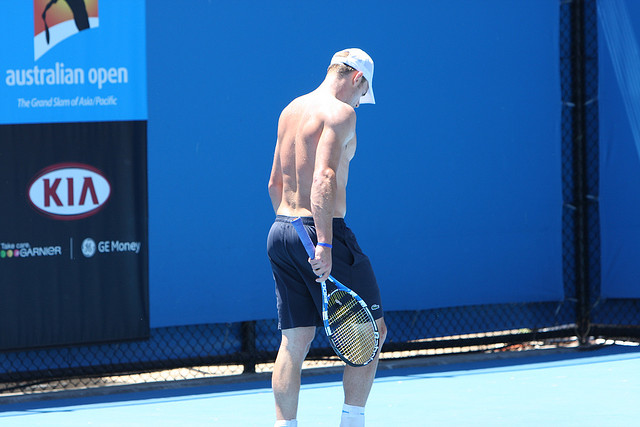Write a very creative question based on this image and a fitting response. Certainly! Here’s a wildly imaginative question and response:

Human: 'If the tennis player's racket could talk, what fascinating stories might it share about its adventures on and off the court?' 
GPT: 'The tennis racket, imbued with years of experience and memories, would animatedly recount tales of epic matches and behind-the-scenes moments. It would start with its creation in a specialized factory, designed with precision and care. As it landed in the hands of the tennis player, it was introduced to the world of high-stakes games and rigorous training sessions.

The racket would recall the thrill of victory during a crucial championship, the loud cheers from the stands, and the electric energy of the crowd. It would share the silent trepidation during intense match points, when every swing determined the fate of the game. Off the court, it would talk about the camaraderie in the locker rooms, the playful jests exchanged with other equipment, and the quiet moments of reflection where the player meticulously cleaned and strung its cords, prepping it for the next big game. The racket’s stories would paint a vivid picture of dedication, passion, and the relentless pursuit of excellence.' 